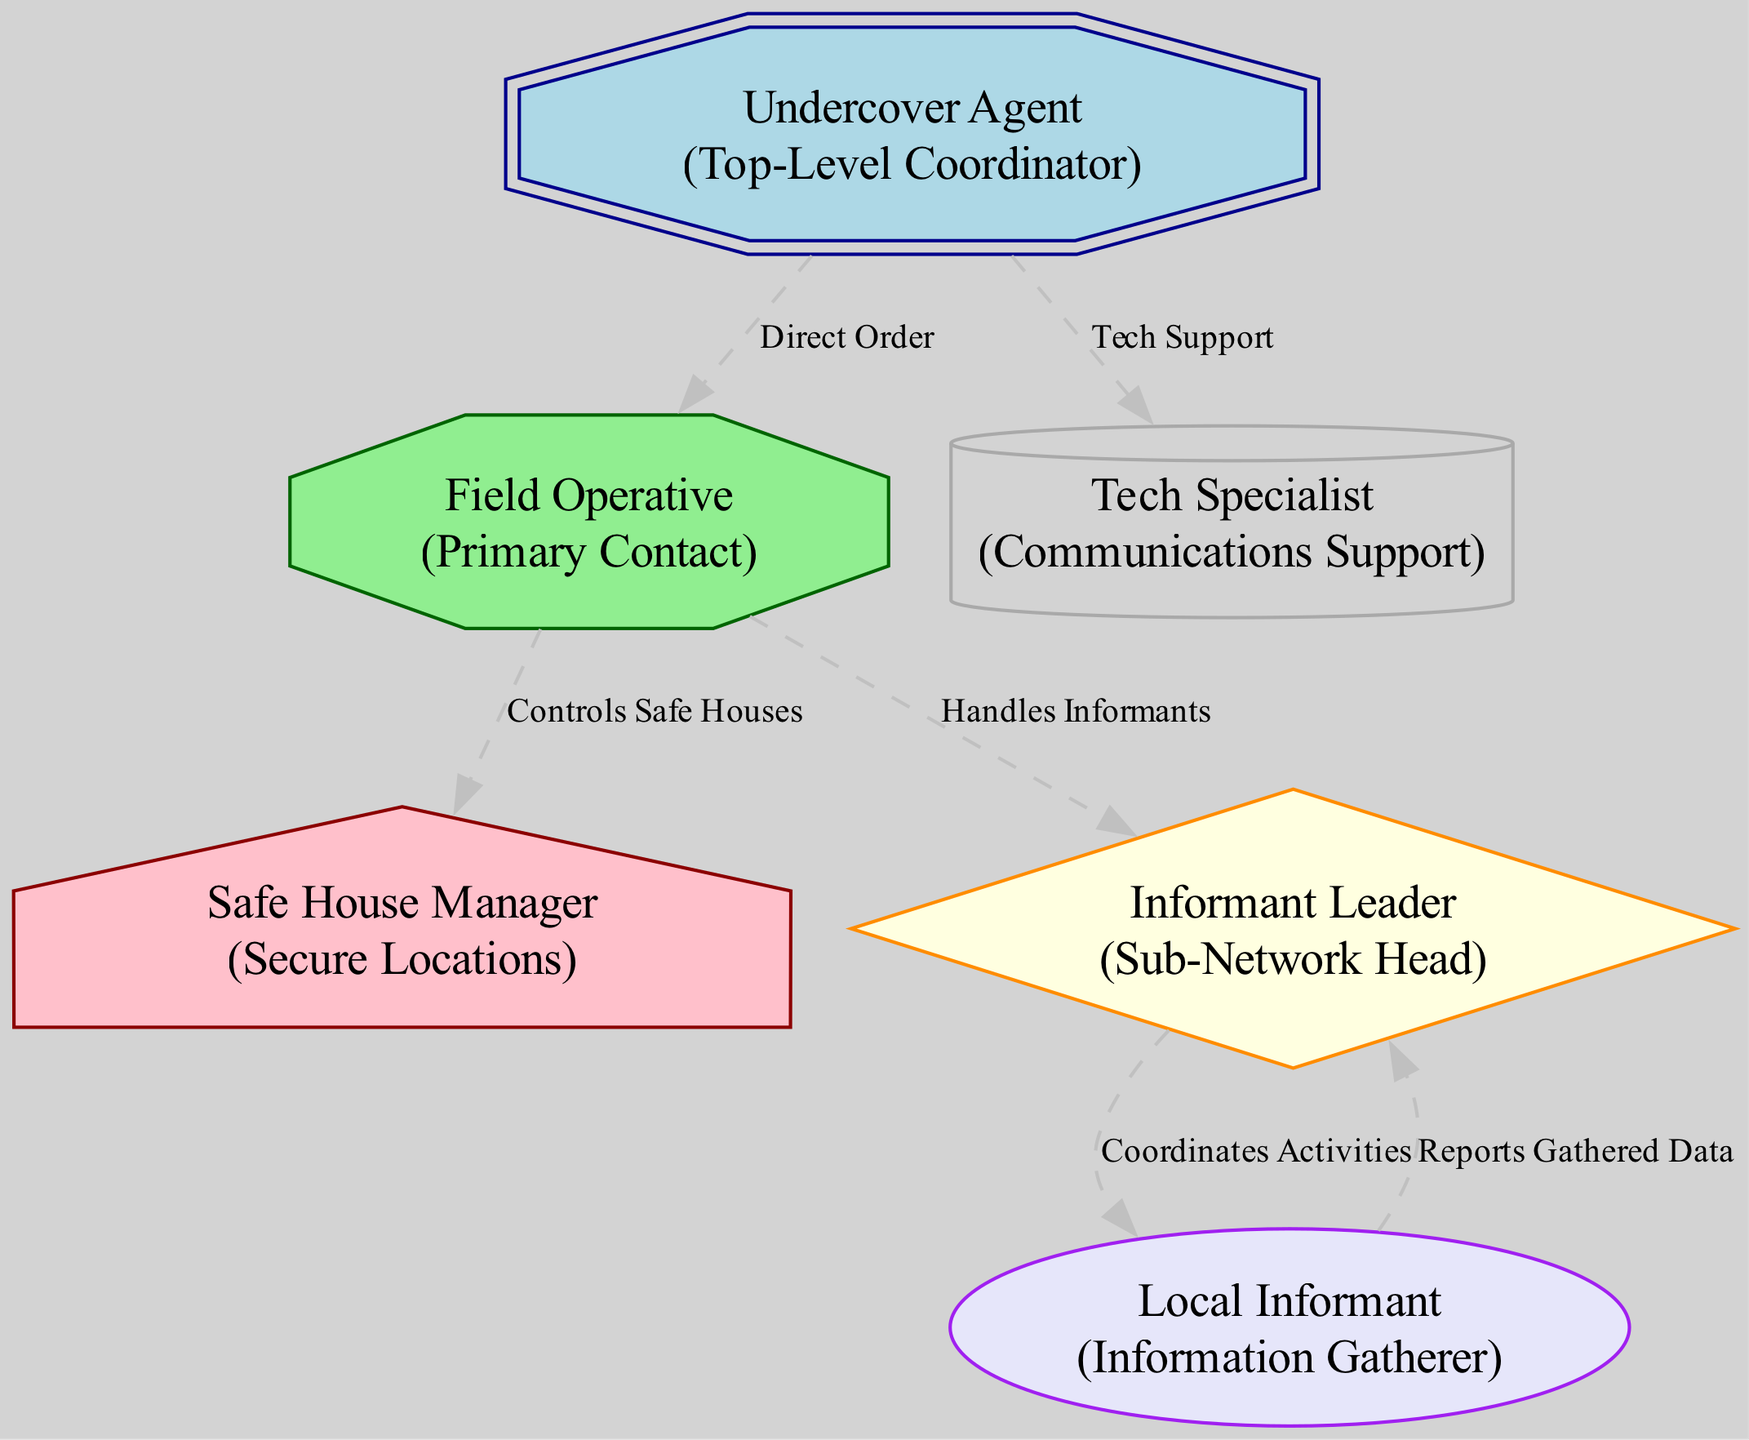What is the role of the node with id "1"? The node with id "1" is labeled "Undercover Agent" and has the role of "Top-Level Coordinator".
Answer: Top-Level Coordinator How many nodes are present in the diagram? By counting the number of items listed under "nodes" in the data, there are six distinct nodes representing different roles in the hierarchy.
Answer: 6 What is the relationship between the "Field Operative" and "Informant Leader"? The "Field Operative" has a direct relationship labeled "Handles Informants" indicating their role in managing the "Informant Leader" and their connections.
Answer: Handles Informants Which node serves as the primary contact for the "Undercover Agent"? The "Field Operative" is directly linked to the "Undercover Agent" through a relationship labeled "Direct Order", indicating their role as the primary contact.
Answer: Field Operative Who controls the safe houses? The "Safe House Manager" directly connects to the "Field Operative" with a relationship labeled "Controls Safe Houses", indicating their role in oversight.
Answer: Safe House Manager How many edges are present in the diagram? By counting the relationships listed under "edges", there are five distinct connections showing the interactions between nodes in the communication structure.
Answer: 5 What role does the "Tech Specialist" play in relation to the "Undercover Agent"? The "Tech Specialist" has a supportive role linked directly to the "Undercover Agent" under the relationship labeled "Tech Support", indicating their assistance in communication needs.
Answer: Tech Support Which node coordinates activities for the "Local Informant"? The "Informant Leader" is connected to the "Local Informant" with the relationship "Coordinates Activities", indicating their responsibility in overseeing the local informants.
Answer: Informant Leader What is the shape associated with the "Local Informant"? In the diagram, the "Local Informant" is represented as an ellipse, which is a specific shape indicating their role as information gatherers.
Answer: Ellipse 